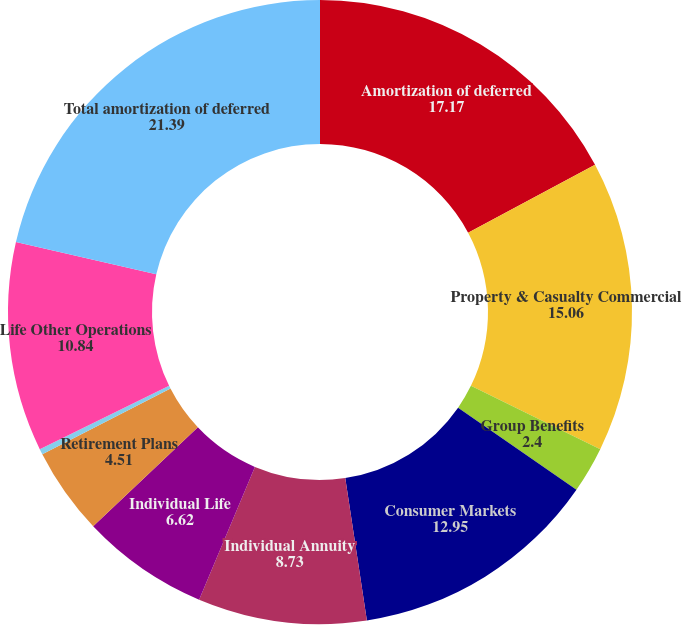Convert chart. <chart><loc_0><loc_0><loc_500><loc_500><pie_chart><fcel>Amortization of deferred<fcel>Property & Casualty Commercial<fcel>Group Benefits<fcel>Consumer Markets<fcel>Individual Annuity<fcel>Individual Life<fcel>Retirement Plans<fcel>Mutual Funds<fcel>Life Other Operations<fcel>Total amortization of deferred<nl><fcel>17.17%<fcel>15.06%<fcel>2.4%<fcel>12.95%<fcel>8.73%<fcel>6.62%<fcel>4.51%<fcel>0.29%<fcel>10.84%<fcel>21.39%<nl></chart> 